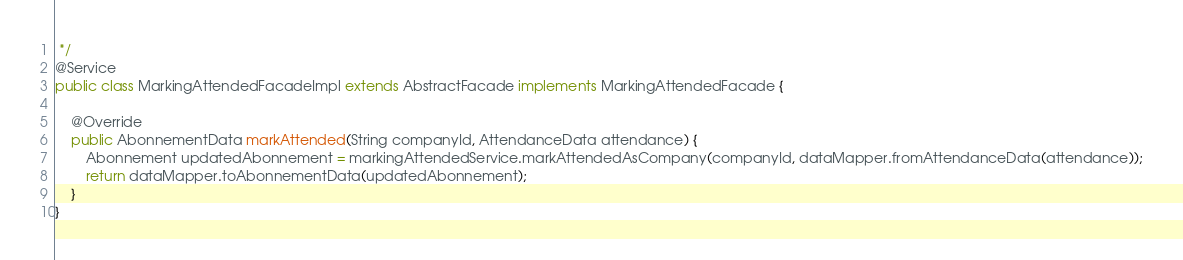Convert code to text. <code><loc_0><loc_0><loc_500><loc_500><_Java_> */
@Service
public class MarkingAttendedFacadeImpl extends AbstractFacade implements MarkingAttendedFacade {

    @Override
    public AbonnementData markAttended(String companyId, AttendanceData attendance) {
        Abonnement updatedAbonnement = markingAttendedService.markAttendedAsCompany(companyId, dataMapper.fromAttendanceData(attendance));
        return dataMapper.toAbonnementData(updatedAbonnement);
    }
}
</code> 